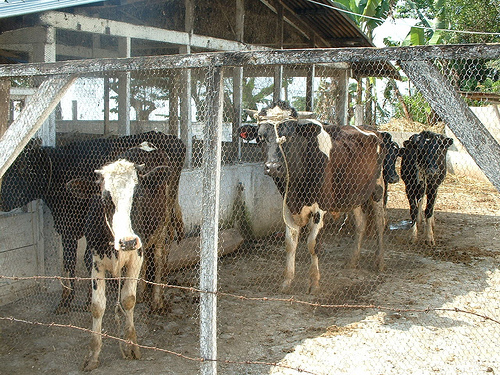The nearby cow to the left who is looking at the camera wears what color down his face?
A. black
B. gray
C. white
D. brown
Answer with the option's letter from the given choices directly. The cow closest to the left side of the image looking directly at the camera prominently displays a white color down its face, framed by black markings on either side. This distinguishing feature gives it a quite unique and striking appearance among the herd. So the correct answer to the question is C: white. 